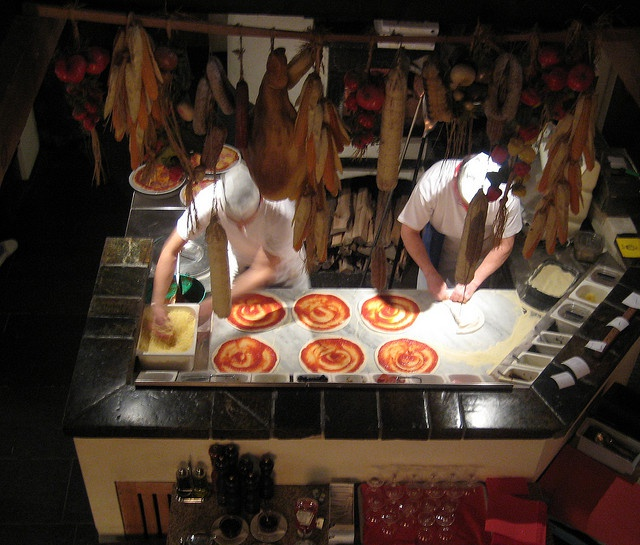Describe the objects in this image and their specific colors. I can see people in black, gray, darkgray, white, and tan tones, people in black, white, maroon, and darkgray tones, pizza in black, orange, ivory, khaki, and salmon tones, pizza in black, orange, salmon, tan, and beige tones, and pizza in black, tan, red, and brown tones in this image. 